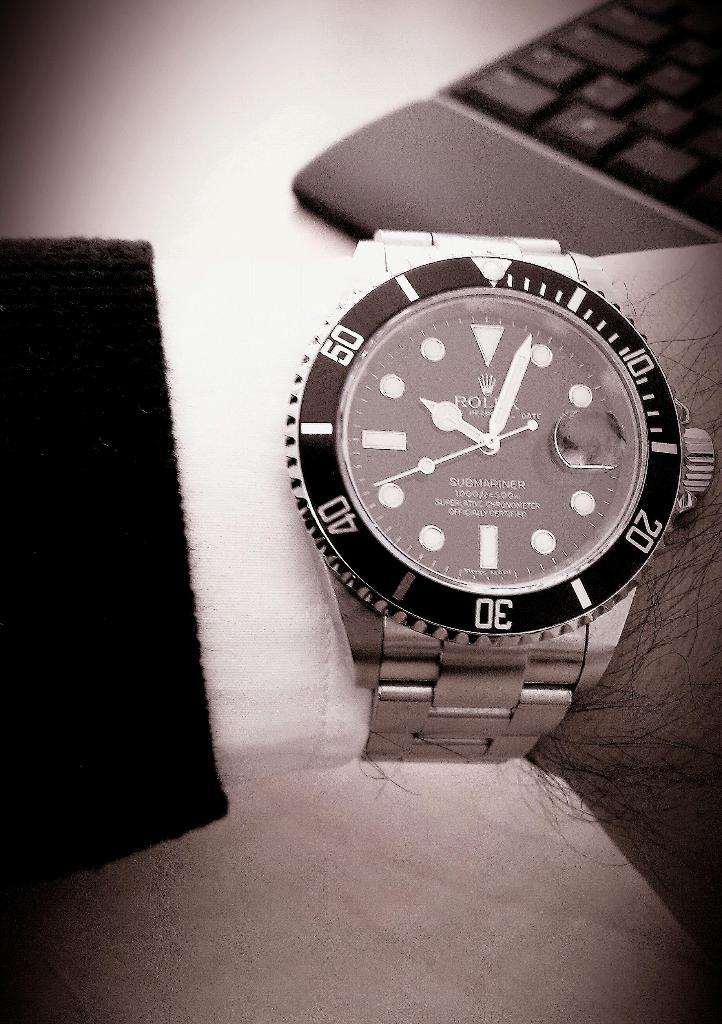<image>
Create a compact narrative representing the image presented. A Rolex watch has numbers 10, 20, 30, 40 and 50 written on the outer ring 